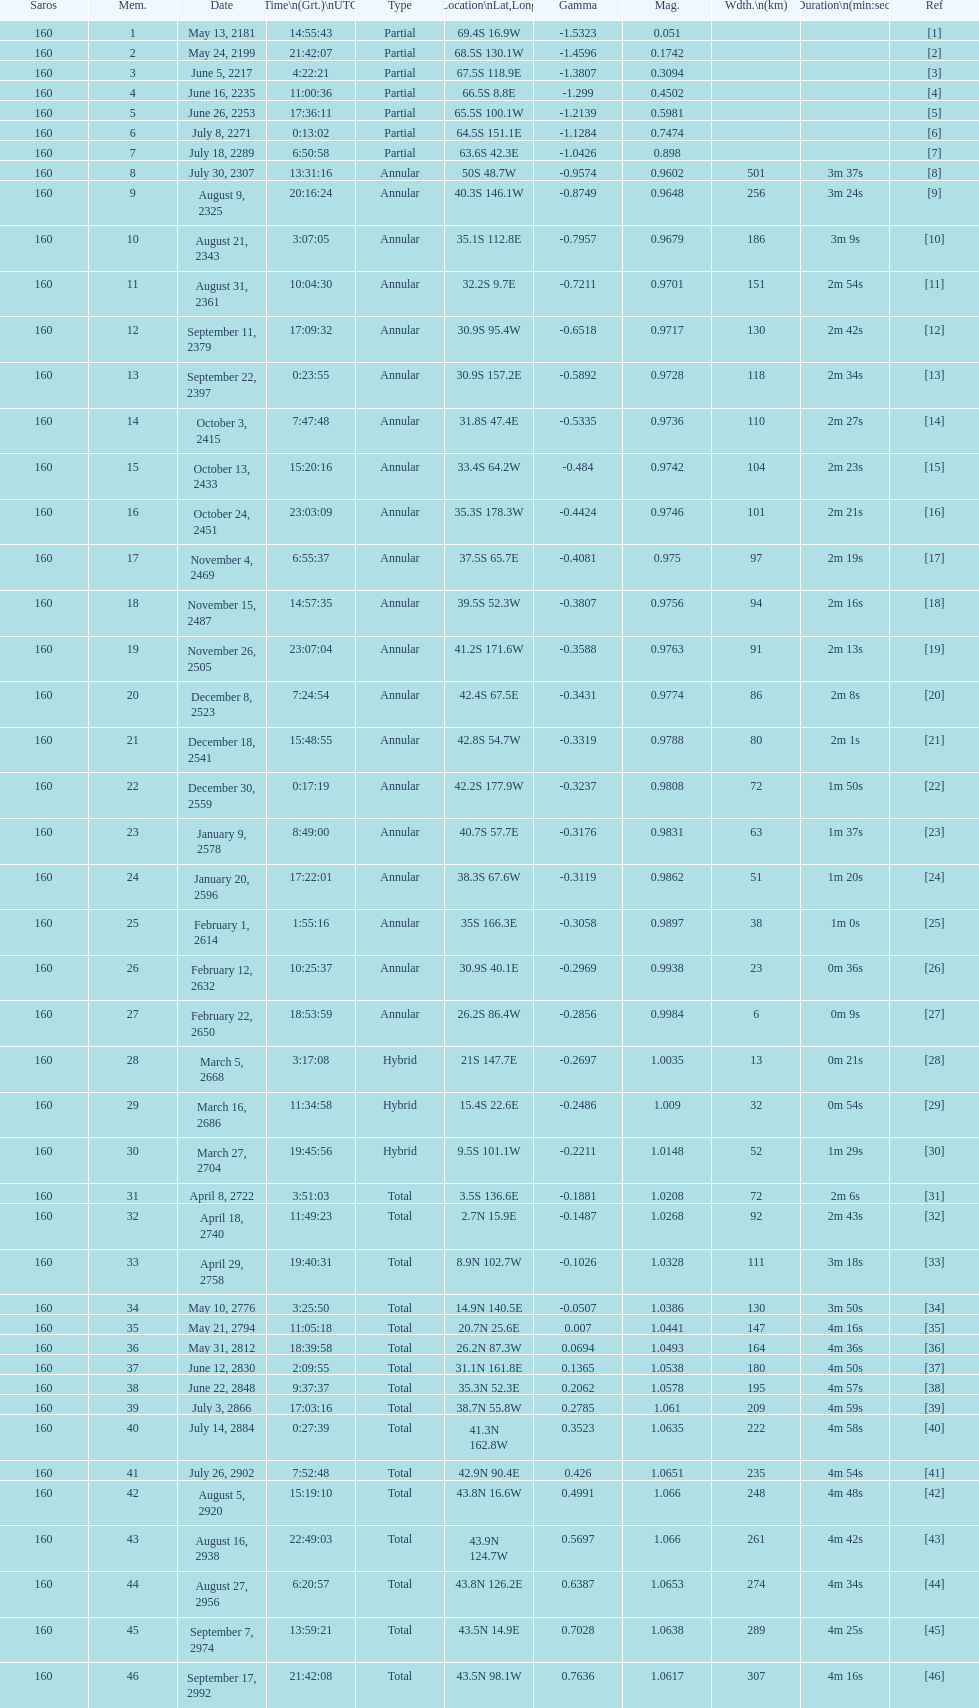How long did the the saros on july 30, 2307 last for? 3m 37s. 